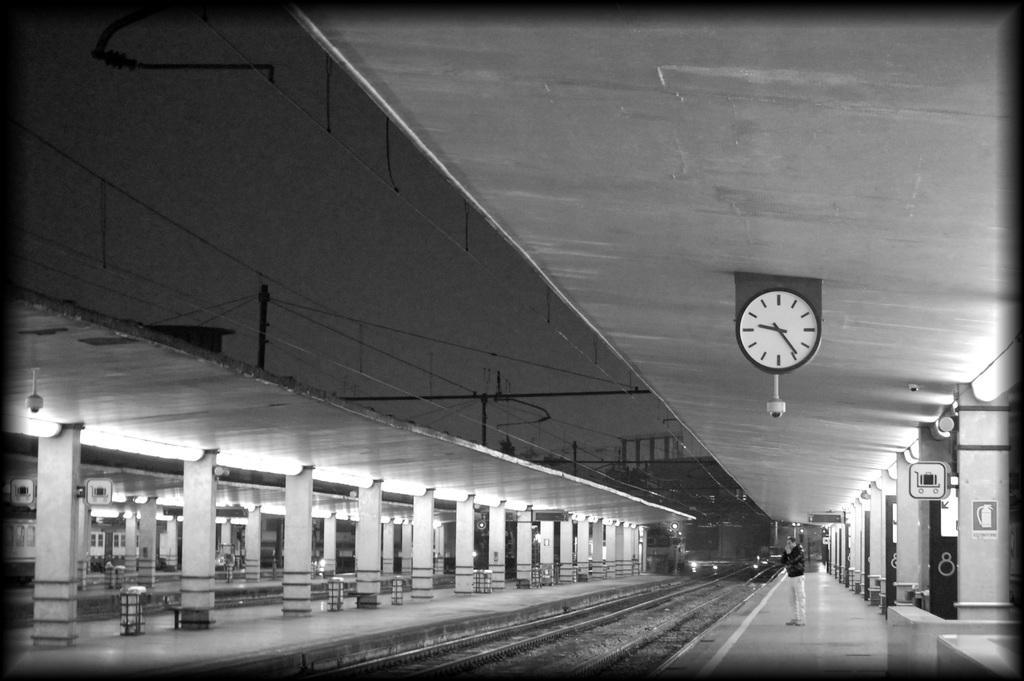How would you summarize this image in a sentence or two? In this image I can see few railway tracks, in front I can see a person standing, I can also see a clock attached to the wall, few lights and the image is in black and white. 